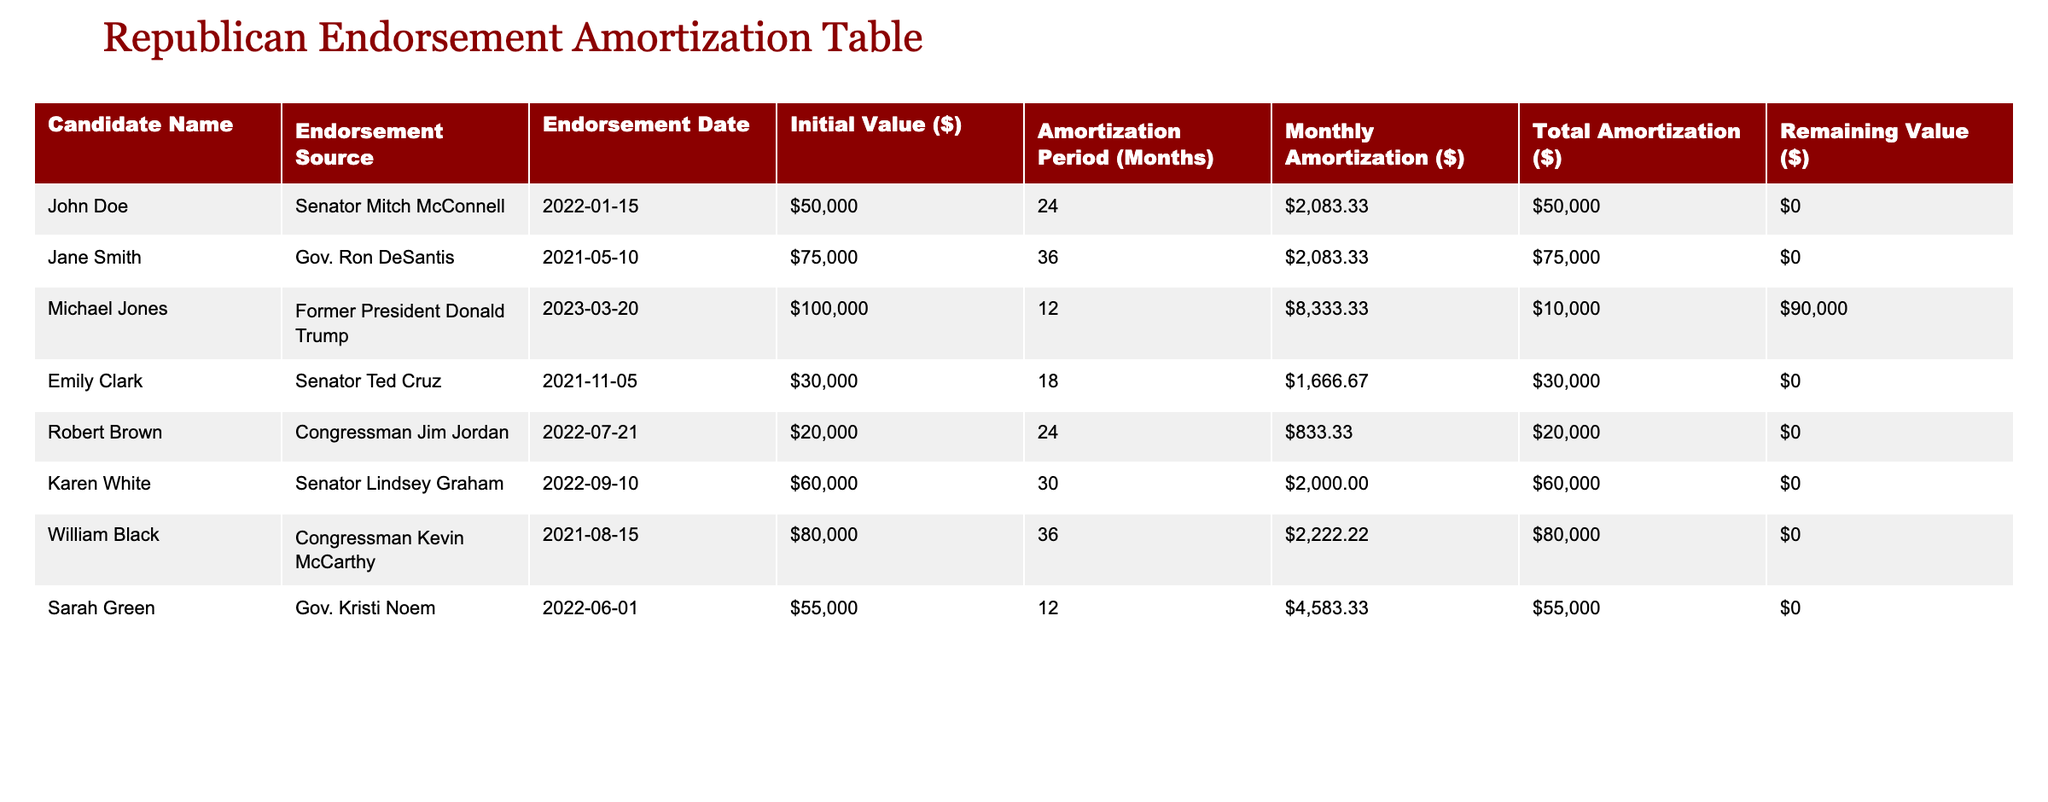What is the initial value of endorsements for Jane Smith? The table shows that Jane Smith has an initial value of $75,000 for her endorsement from Gov. Ron DeSantis.
Answer: $75,000 How many months is the amortization period for the endorsement received by Michael Jones? The table indicates that Michael Jones has an amortization period of 12 months for his endorsement from Former President Donald Trump.
Answer: 12 months What is the total amortization value for all the candidates listed in the table? To find the total amortization value, we sum the Total Amortization ($) column: $50,000 (John Doe) + $75,000 (Jane Smith) + $10,000 (Michael Jones) + $30,000 (Emily Clark) + $20,000 (Robert Brown) + $60,000 (Karen White) + $80,000 (William Black) + $55,000 (Sarah Green) = $330,000.
Answer: $330,000 Is there any candidate whose remaining value is zero? Yes, all candidates listed in the table have a remaining value of zero, indicating that their endorsements have been fully amortized.
Answer: Yes Which candidate has the highest remaining value, and what is it? Among the candidates, Michael Jones has the highest remaining value of $90,000 from his endorsement from Former President Donald Trump, as he has only partially amortized it.
Answer: $90,000 How many candidates received endorsements that are amortized over more than 24 months? From the table, there are four candidates with an amortization period longer than 24 months: Jane Smith (36 months), William Black (36 months), and Karen White (30 months). Therefore, the total is four candidates.
Answer: 4 candidates What is the average initial value of endorsements for the candidates listed? To compute the average, we calculate the sum of all initial values: $50,000 + $75,000 + $100,000 + $30,000 + $20,000 + $60,000 + $80,000 + $55,000 = $470,000. There are eight candidates, so the average is $470,000 / 8 = $58,750.
Answer: $58,750 How many endorsements are from governmental figures (Senators or Governors)? In the table, endorsements from governmental figures include those from Senator Mitch McConnell, Gov. Ron DeSantis, Senator Ted Cruz, Senator Lindsey Graham, Gov. Kristi Noem, totaling four endorsements from governmental figures.
Answer: 4 endorsements 